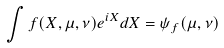<formula> <loc_0><loc_0><loc_500><loc_500>\int f ( X , \mu , \nu ) e ^ { i X } d X = \psi _ { f } ( \mu , \nu )</formula> 